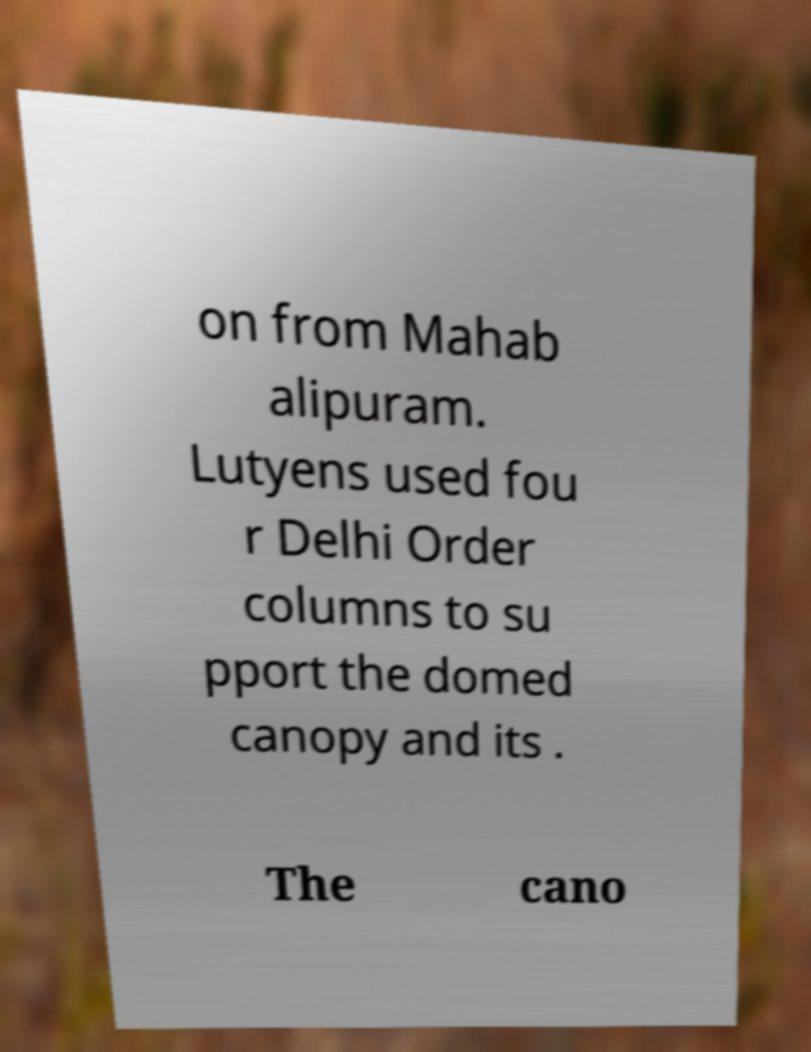Please identify and transcribe the text found in this image. on from Mahab alipuram. Lutyens used fou r Delhi Order columns to su pport the domed canopy and its . The cano 